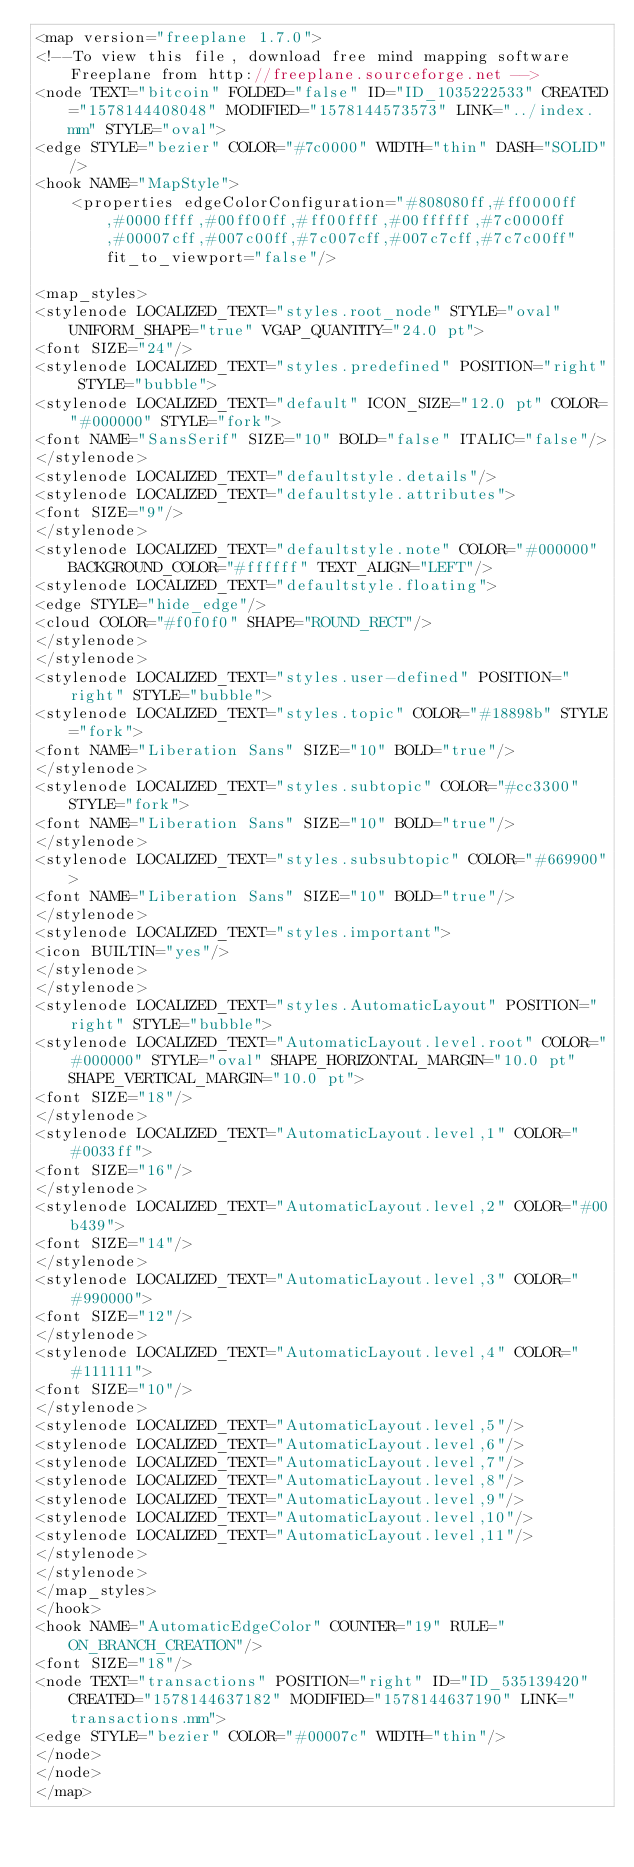<code> <loc_0><loc_0><loc_500><loc_500><_ObjectiveC_><map version="freeplane 1.7.0">
<!--To view this file, download free mind mapping software Freeplane from http://freeplane.sourceforge.net -->
<node TEXT="bitcoin" FOLDED="false" ID="ID_1035222533" CREATED="1578144408048" MODIFIED="1578144573573" LINK="../index.mm" STYLE="oval">
<edge STYLE="bezier" COLOR="#7c0000" WIDTH="thin" DASH="SOLID"/>
<hook NAME="MapStyle">
    <properties edgeColorConfiguration="#808080ff,#ff0000ff,#0000ffff,#00ff00ff,#ff00ffff,#00ffffff,#7c0000ff,#00007cff,#007c00ff,#7c007cff,#007c7cff,#7c7c00ff" fit_to_viewport="false"/>

<map_styles>
<stylenode LOCALIZED_TEXT="styles.root_node" STYLE="oval" UNIFORM_SHAPE="true" VGAP_QUANTITY="24.0 pt">
<font SIZE="24"/>
<stylenode LOCALIZED_TEXT="styles.predefined" POSITION="right" STYLE="bubble">
<stylenode LOCALIZED_TEXT="default" ICON_SIZE="12.0 pt" COLOR="#000000" STYLE="fork">
<font NAME="SansSerif" SIZE="10" BOLD="false" ITALIC="false"/>
</stylenode>
<stylenode LOCALIZED_TEXT="defaultstyle.details"/>
<stylenode LOCALIZED_TEXT="defaultstyle.attributes">
<font SIZE="9"/>
</stylenode>
<stylenode LOCALIZED_TEXT="defaultstyle.note" COLOR="#000000" BACKGROUND_COLOR="#ffffff" TEXT_ALIGN="LEFT"/>
<stylenode LOCALIZED_TEXT="defaultstyle.floating">
<edge STYLE="hide_edge"/>
<cloud COLOR="#f0f0f0" SHAPE="ROUND_RECT"/>
</stylenode>
</stylenode>
<stylenode LOCALIZED_TEXT="styles.user-defined" POSITION="right" STYLE="bubble">
<stylenode LOCALIZED_TEXT="styles.topic" COLOR="#18898b" STYLE="fork">
<font NAME="Liberation Sans" SIZE="10" BOLD="true"/>
</stylenode>
<stylenode LOCALIZED_TEXT="styles.subtopic" COLOR="#cc3300" STYLE="fork">
<font NAME="Liberation Sans" SIZE="10" BOLD="true"/>
</stylenode>
<stylenode LOCALIZED_TEXT="styles.subsubtopic" COLOR="#669900">
<font NAME="Liberation Sans" SIZE="10" BOLD="true"/>
</stylenode>
<stylenode LOCALIZED_TEXT="styles.important">
<icon BUILTIN="yes"/>
</stylenode>
</stylenode>
<stylenode LOCALIZED_TEXT="styles.AutomaticLayout" POSITION="right" STYLE="bubble">
<stylenode LOCALIZED_TEXT="AutomaticLayout.level.root" COLOR="#000000" STYLE="oval" SHAPE_HORIZONTAL_MARGIN="10.0 pt" SHAPE_VERTICAL_MARGIN="10.0 pt">
<font SIZE="18"/>
</stylenode>
<stylenode LOCALIZED_TEXT="AutomaticLayout.level,1" COLOR="#0033ff">
<font SIZE="16"/>
</stylenode>
<stylenode LOCALIZED_TEXT="AutomaticLayout.level,2" COLOR="#00b439">
<font SIZE="14"/>
</stylenode>
<stylenode LOCALIZED_TEXT="AutomaticLayout.level,3" COLOR="#990000">
<font SIZE="12"/>
</stylenode>
<stylenode LOCALIZED_TEXT="AutomaticLayout.level,4" COLOR="#111111">
<font SIZE="10"/>
</stylenode>
<stylenode LOCALIZED_TEXT="AutomaticLayout.level,5"/>
<stylenode LOCALIZED_TEXT="AutomaticLayout.level,6"/>
<stylenode LOCALIZED_TEXT="AutomaticLayout.level,7"/>
<stylenode LOCALIZED_TEXT="AutomaticLayout.level,8"/>
<stylenode LOCALIZED_TEXT="AutomaticLayout.level,9"/>
<stylenode LOCALIZED_TEXT="AutomaticLayout.level,10"/>
<stylenode LOCALIZED_TEXT="AutomaticLayout.level,11"/>
</stylenode>
</stylenode>
</map_styles>
</hook>
<hook NAME="AutomaticEdgeColor" COUNTER="19" RULE="ON_BRANCH_CREATION"/>
<font SIZE="18"/>
<node TEXT="transactions" POSITION="right" ID="ID_535139420" CREATED="1578144637182" MODIFIED="1578144637190" LINK="transactions.mm">
<edge STYLE="bezier" COLOR="#00007c" WIDTH="thin"/>
</node>
</node>
</map>
</code> 